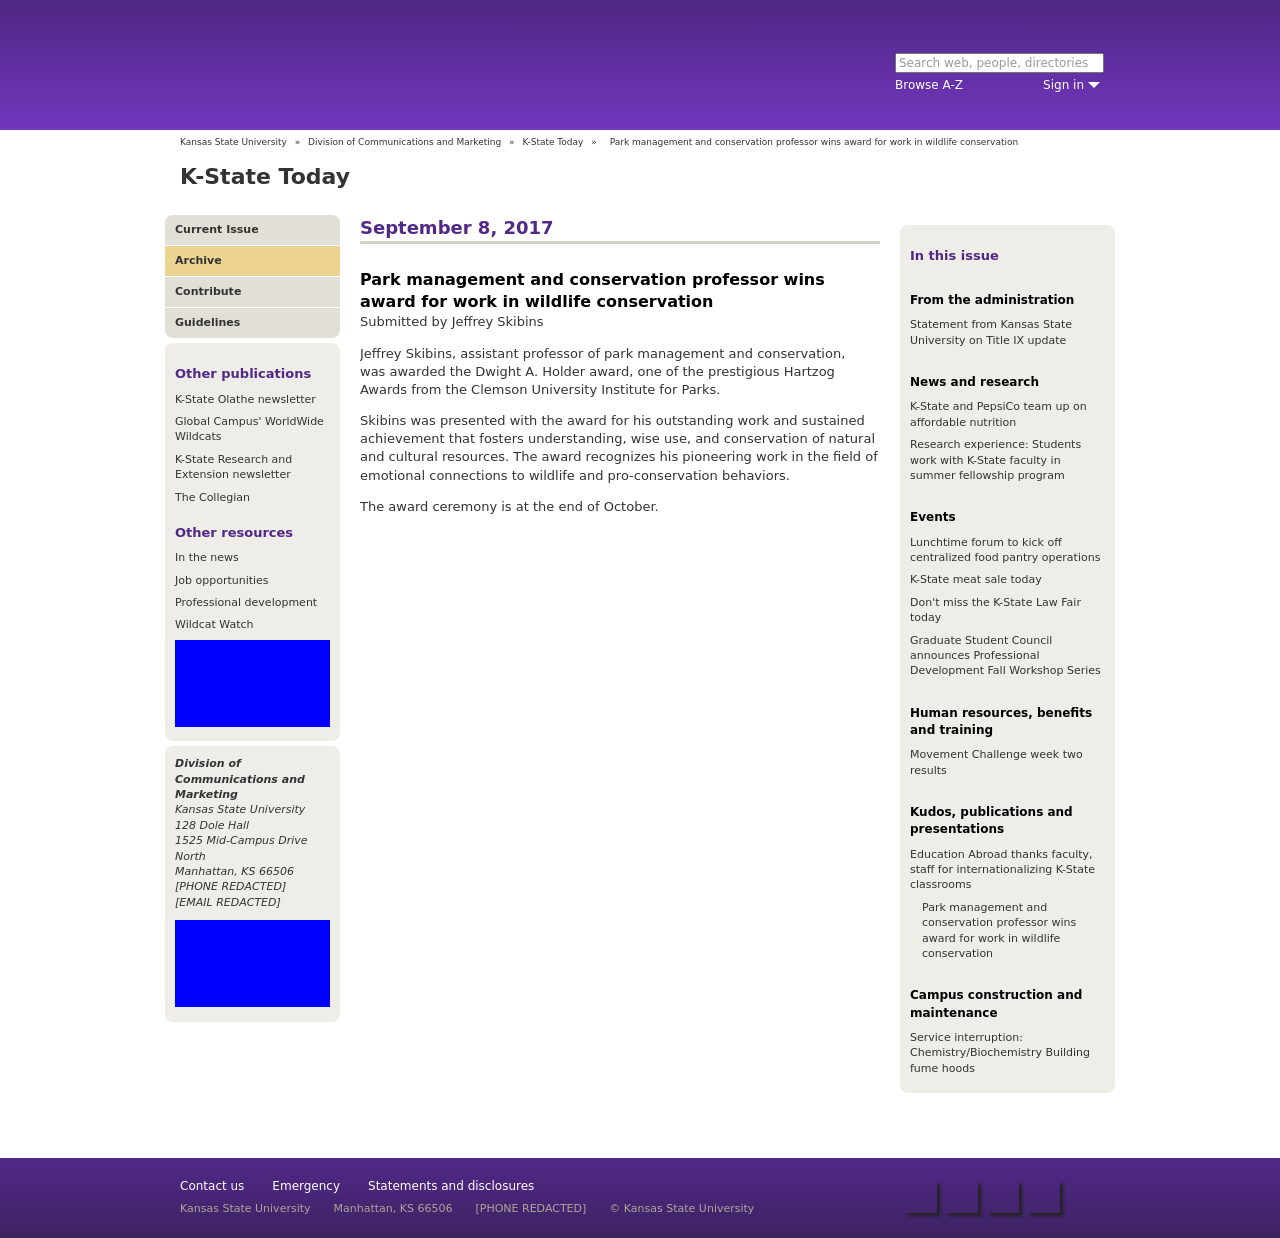What specific awards and achievements are highlighted in this image regarding the professor's recognition? The image highlights the professor's achievement of receiving the Dwight A. Holder award from the Clemson University Institute for Parks for his work in wildlife conservation. This recognition is due to his outstanding work and sustained contributions to park management and conservation, emphasizing his development of cultural resources and fostering connections to wildlife. 